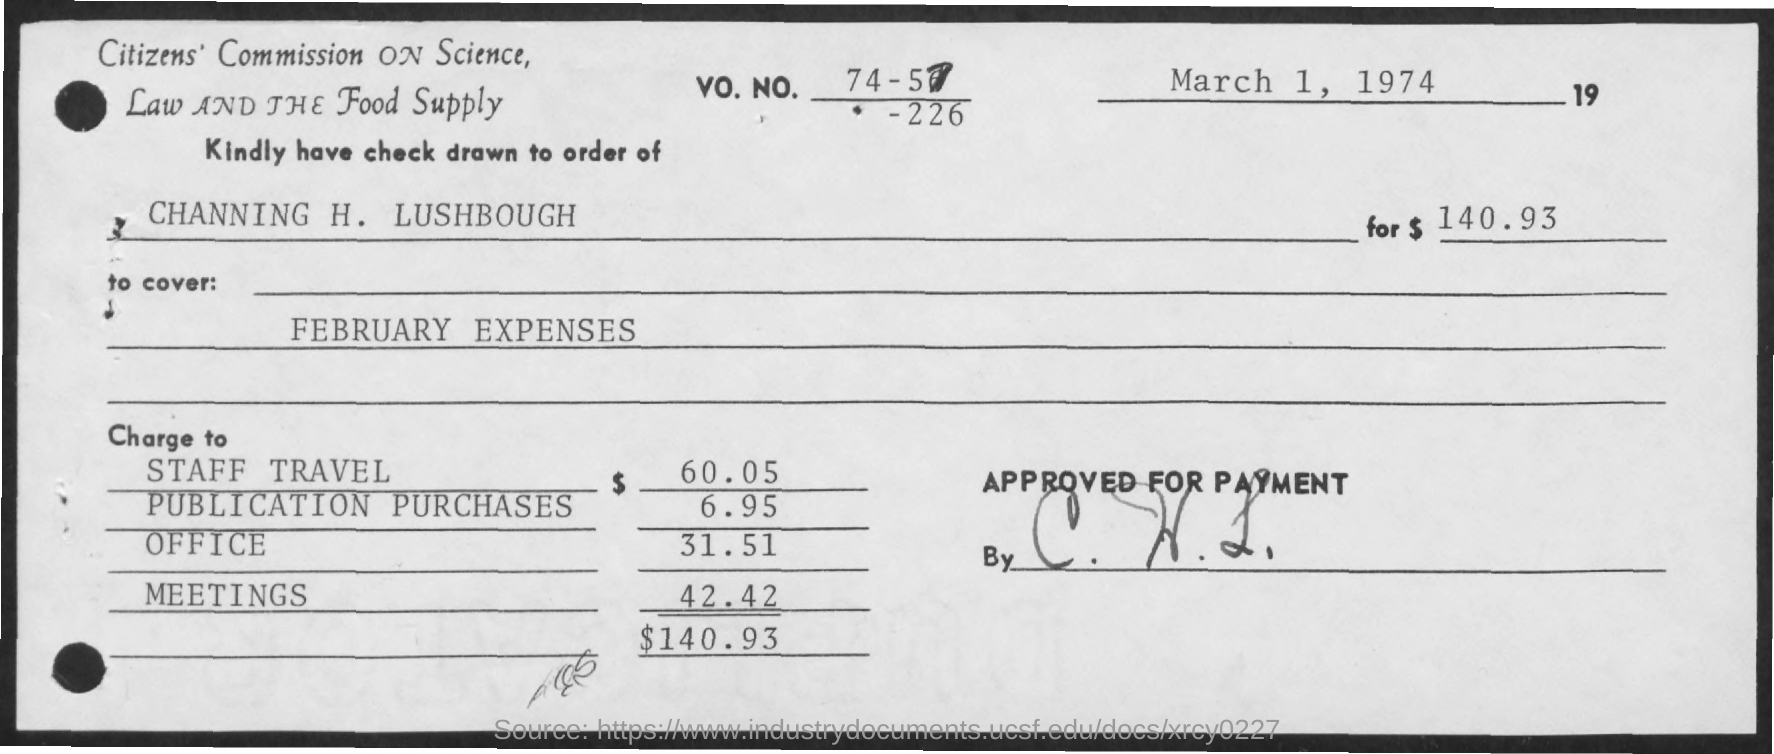When is the Memorandum dated on ?
Your answer should be very brief. March 1, 1974. Which month Expenses is showing ?
Provide a short and direct response. February. 